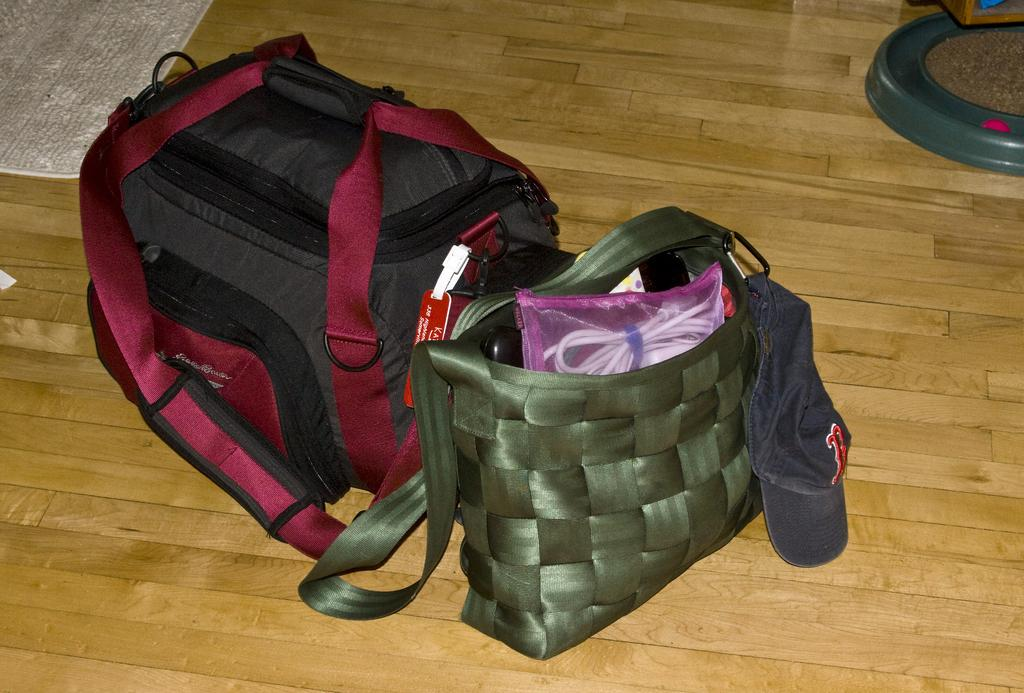How many bags are on the floor in the image? There are two bags on the floor in the image. What is on top of one of the bags? A cap is on one of the bags. What is the shape of the object on the floor? There is a round object on the floor. What is the material of the object on the floor? There is a wooden object on the floor. What is covering the floor in the image? There is a carpet on the floor. What type of punishment is being administered to the bags in the image? There is no punishment being administered to the bags in the image; they are simply sitting on the floor. What kind of seed can be seen growing on the wooden object in the image? There are no seeds present in the image, and the wooden object is not a plant or a surface where seeds would grow. 